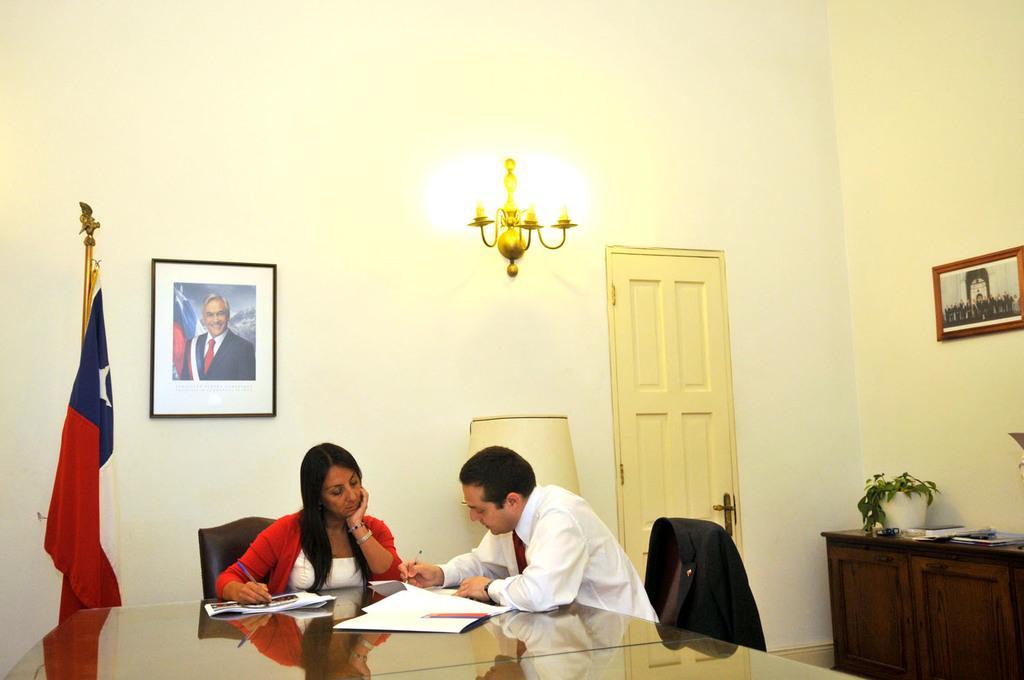Can you describe this image briefly? In center we can see two persons were sitting on the chair around the table. On table we can see papers,book,pen. Coming to back we can see photo frame,flag,lamp,cupboard,plant,door,light and wall. 